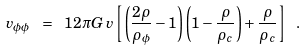Convert formula to latex. <formula><loc_0><loc_0><loc_500><loc_500>v _ { \phi \phi } \ = \ 1 2 \pi G \, v \left [ \left ( \frac { 2 \rho } { \rho _ { \phi } } - 1 \right ) \left ( 1 - \frac { \rho } { \rho _ { c } } \right ) + \frac { \rho } { \rho _ { c } } \right ] \ .</formula> 